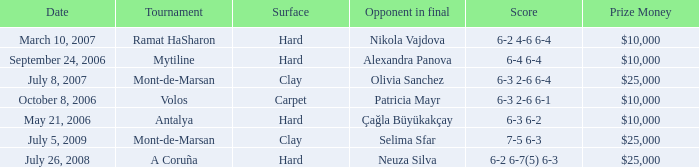Who was the opponent on carpet in a final? Patricia Mayr. 